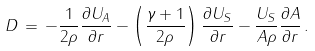<formula> <loc_0><loc_0><loc_500><loc_500>D \, = \, - \frac { 1 } { 2 \rho } \frac { \partial U _ { A } } { \partial r } - \left ( \frac { \gamma + 1 } { 2 \rho } \right ) \frac { \partial U _ { S } } { \partial r } - \frac { U _ { S } } { A \rho } \frac { \partial A } { \partial r } \, .</formula> 